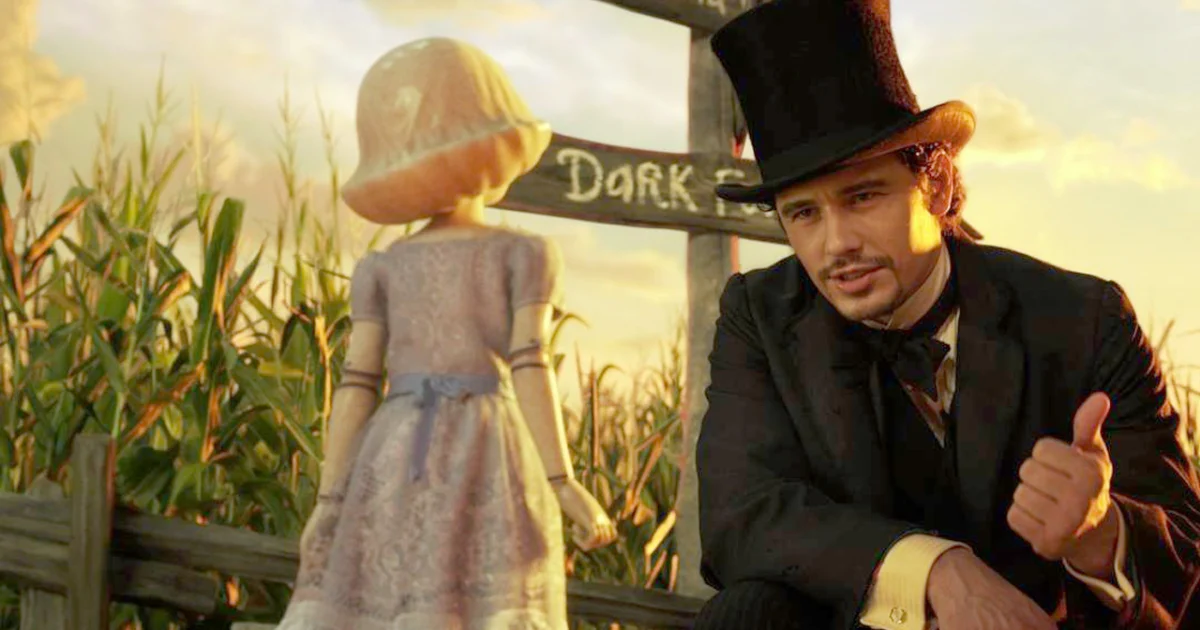What do you think is going on in this snapshot?
 In the image, actor James Franco, portraying the character of Oz in the movie "Oz the Great and Powerful", is seen in a vibrant scene filled with hues of yellow and green. He is dressed in a black suit and top hat, adding a stark contrast to the colorful background. Oz is crouched down, bringing himself to eye level with a doll-like character known as China Girl. The interaction between the two characters appears to be taking place in a cornfield, with a wooden sign that reads "Dark" visible in the background. The overall composition of the image suggests a moment of dialogue or connection between Oz and China Girl. 